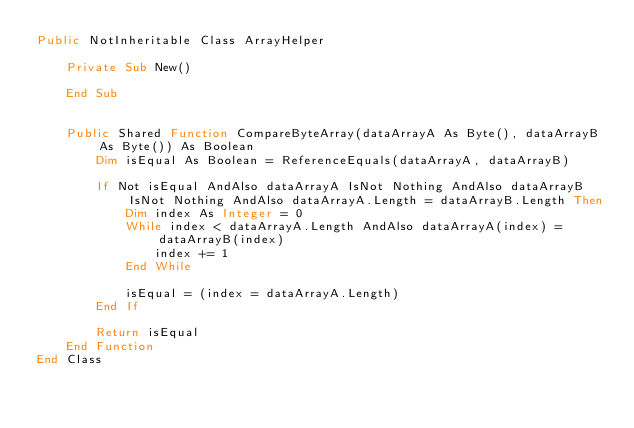Convert code to text. <code><loc_0><loc_0><loc_500><loc_500><_VisualBasic_>Public NotInheritable Class ArrayHelper

    Private Sub New()

    End Sub


    Public Shared Function CompareByteArray(dataArrayA As Byte(), dataArrayB As Byte()) As Boolean
        Dim isEqual As Boolean = ReferenceEquals(dataArrayA, dataArrayB)

        If Not isEqual AndAlso dataArrayA IsNot Nothing AndAlso dataArrayB IsNot Nothing AndAlso dataArrayA.Length = dataArrayB.Length Then
            Dim index As Integer = 0
            While index < dataArrayA.Length AndAlso dataArrayA(index) = dataArrayB(index)
                index += 1
            End While

            isEqual = (index = dataArrayA.Length)
        End If

        Return isEqual
    End Function
End Class
</code> 